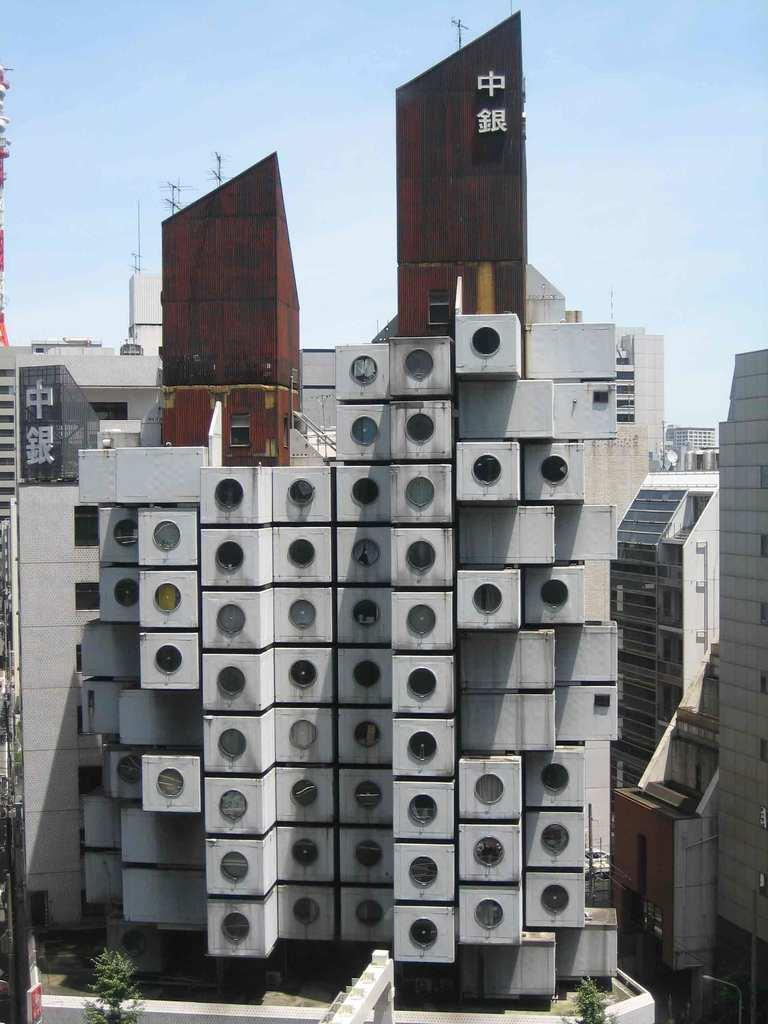<image>
Relay a brief, clear account of the picture shown. the outside of a building with chinese lettering at the top 